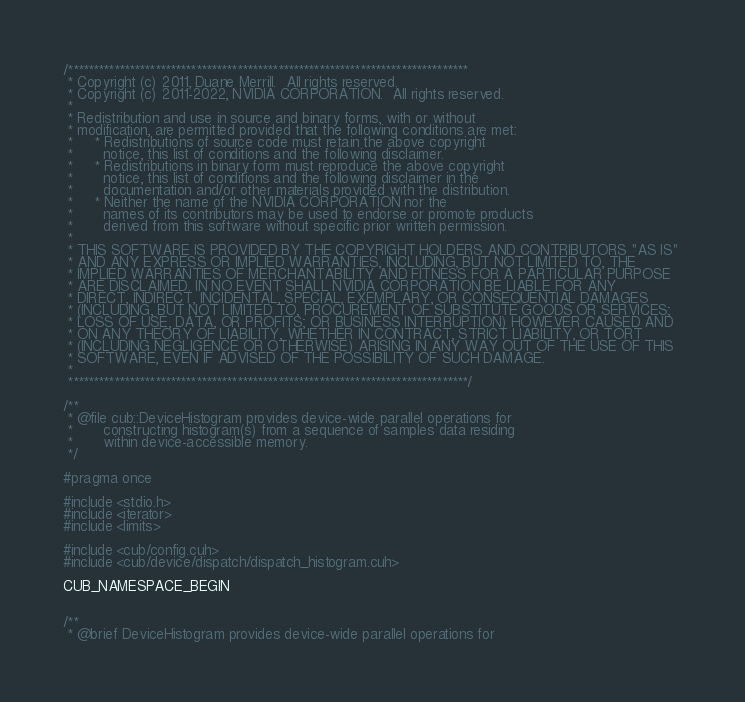<code> <loc_0><loc_0><loc_500><loc_500><_Cuda_>/******************************************************************************
 * Copyright (c) 2011, Duane Merrill.  All rights reserved.
 * Copyright (c) 2011-2022, NVIDIA CORPORATION.  All rights reserved.
 *
 * Redistribution and use in source and binary forms, with or without
 * modification, are permitted provided that the following conditions are met:
 *     * Redistributions of source code must retain the above copyright
 *       notice, this list of conditions and the following disclaimer.
 *     * Redistributions in binary form must reproduce the above copyright
 *       notice, this list of conditions and the following disclaimer in the
 *       documentation and/or other materials provided with the distribution.
 *     * Neither the name of the NVIDIA CORPORATION nor the
 *       names of its contributors may be used to endorse or promote products
 *       derived from this software without specific prior written permission.
 *
 * THIS SOFTWARE IS PROVIDED BY THE COPYRIGHT HOLDERS AND CONTRIBUTORS "AS IS" 
 * AND ANY EXPRESS OR IMPLIED WARRANTIES, INCLUDING, BUT NOT LIMITED TO, THE 
 * IMPLIED WARRANTIES OF MERCHANTABILITY AND FITNESS FOR A PARTICULAR PURPOSE 
 * ARE DISCLAIMED. IN NO EVENT SHALL NVIDIA CORPORATION BE LIABLE FOR ANY
 * DIRECT, INDIRECT, INCIDENTAL, SPECIAL, EXEMPLARY, OR CONSEQUENTIAL DAMAGES
 * (INCLUDING, BUT NOT LIMITED TO, PROCUREMENT OF SUBSTITUTE GOODS OR SERVICES;
 * LOSS OF USE, DATA, OR PROFITS; OR BUSINESS INTERRUPTION) HOWEVER CAUSED AND
 * ON ANY THEORY OF LIABILITY, WHETHER IN CONTRACT, STRICT LIABILITY, OR TORT
 * (INCLUDING NEGLIGENCE OR OTHERWISE) ARISING IN ANY WAY OUT OF THE USE OF THIS
 * SOFTWARE, EVEN IF ADVISED OF THE POSSIBILITY OF SUCH DAMAGE.
 *
 ******************************************************************************/

/**
 * @file cub::DeviceHistogram provides device-wide parallel operations for 
 *       constructing histogram(s) from a sequence of samples data residing 
 *       within device-accessible memory.
 */

#pragma once

#include <stdio.h>
#include <iterator>
#include <limits>

#include <cub/config.cuh>
#include <cub/device/dispatch/dispatch_histogram.cuh>

CUB_NAMESPACE_BEGIN


/**
 * @brief DeviceHistogram provides device-wide parallel operations for </code> 